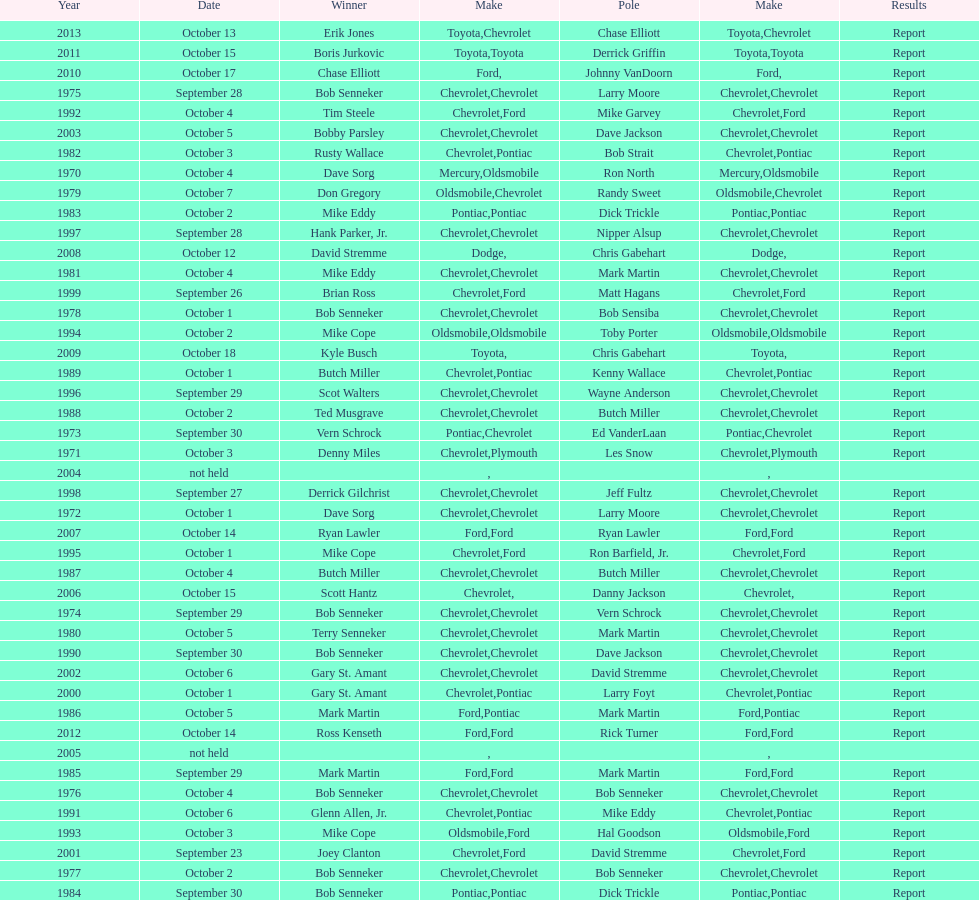Who on the list has the highest number of consecutive wins? Bob Senneker. 